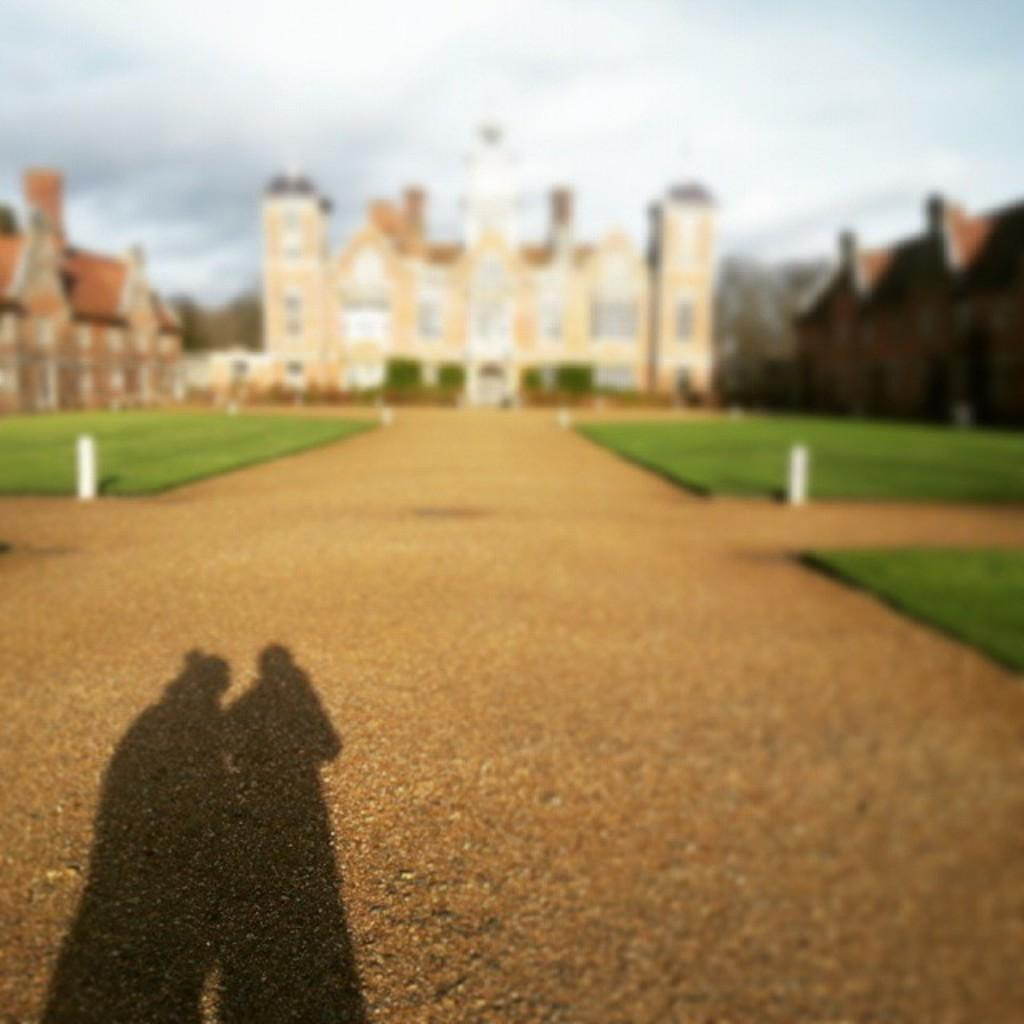What can be seen in the image that is not in focus? The background of the image is blurry. What is present in the image that might indicate a specific time of day? There is a shadow in the image, which could suggest the time of day. What type of structures are visible in the image? There are buildings visible in the image. How many apples are being discovered in the image? There are no apples or any indication of a discovery process present in the image. What type of jelly is visible on the buildings in the image? There is no jelly visible on the buildings in the image. 